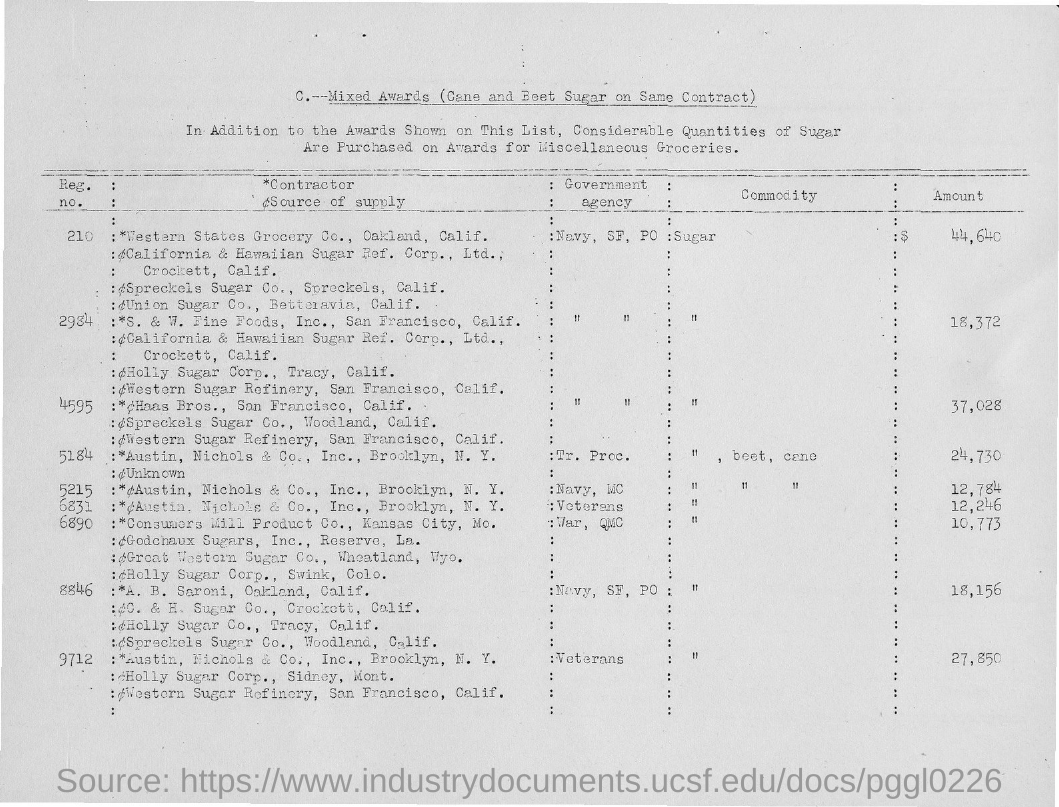What is the amount for sugar with Reg.no. 210?
Offer a terse response. $ 44,640. What is the amount for sugar with Reg.no. 4595?
Provide a succinct answer. 37,028. 